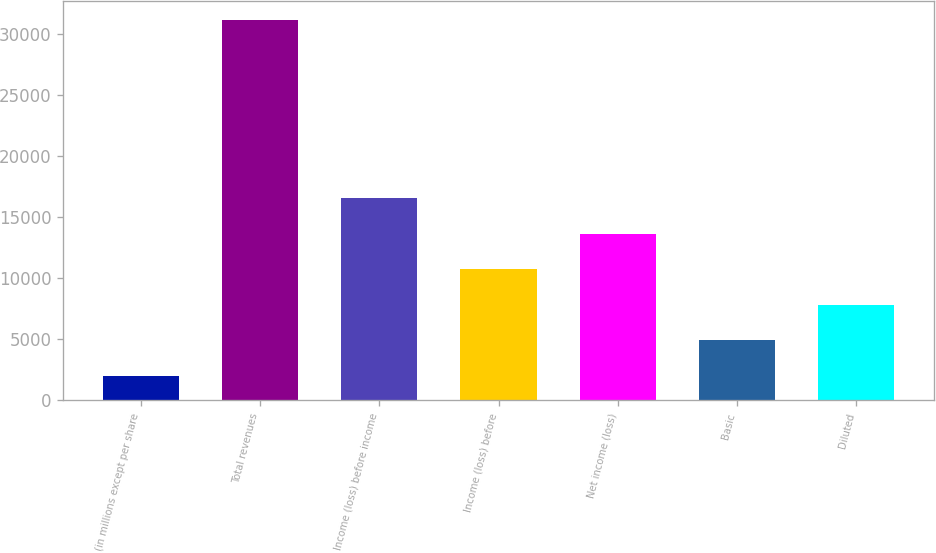Convert chart. <chart><loc_0><loc_0><loc_500><loc_500><bar_chart><fcel>(in millions except per share<fcel>Total revenues<fcel>Income (loss) before income<fcel>Income (loss) before<fcel>Net income (loss)<fcel>Basic<fcel>Diluted<nl><fcel>2007<fcel>31150<fcel>16578.5<fcel>10749.9<fcel>13664.2<fcel>4921.3<fcel>7835.6<nl></chart> 